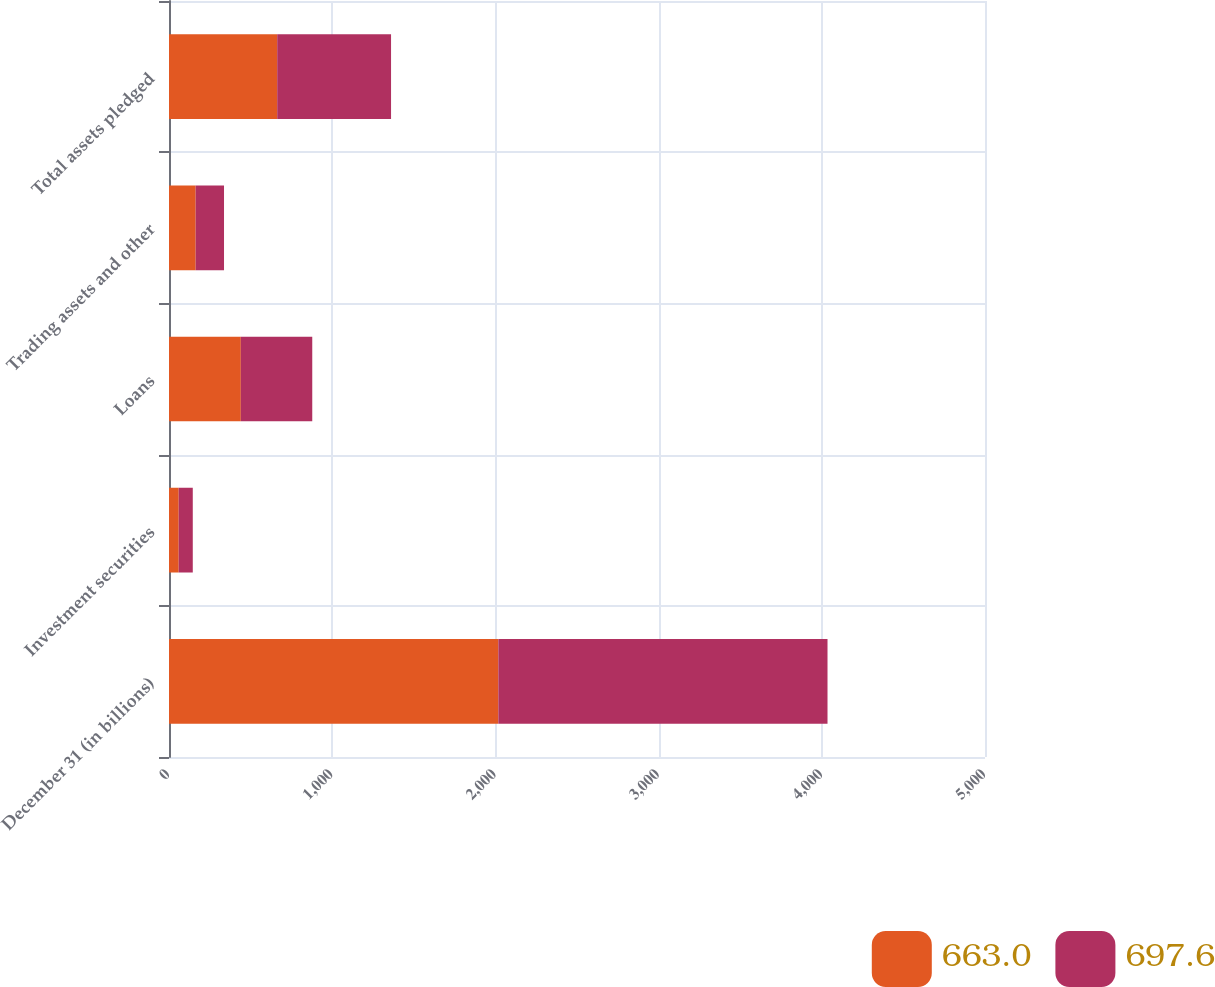<chart> <loc_0><loc_0><loc_500><loc_500><stacked_bar_chart><ecel><fcel>December 31 (in billions)<fcel>Investment securities<fcel>Loans<fcel>Trading assets and other<fcel>Total assets pledged<nl><fcel>663<fcel>2018<fcel>59.5<fcel>440.1<fcel>163.4<fcel>663<nl><fcel>697.6<fcel>2017<fcel>86.2<fcel>437.7<fcel>173.7<fcel>697.6<nl></chart> 